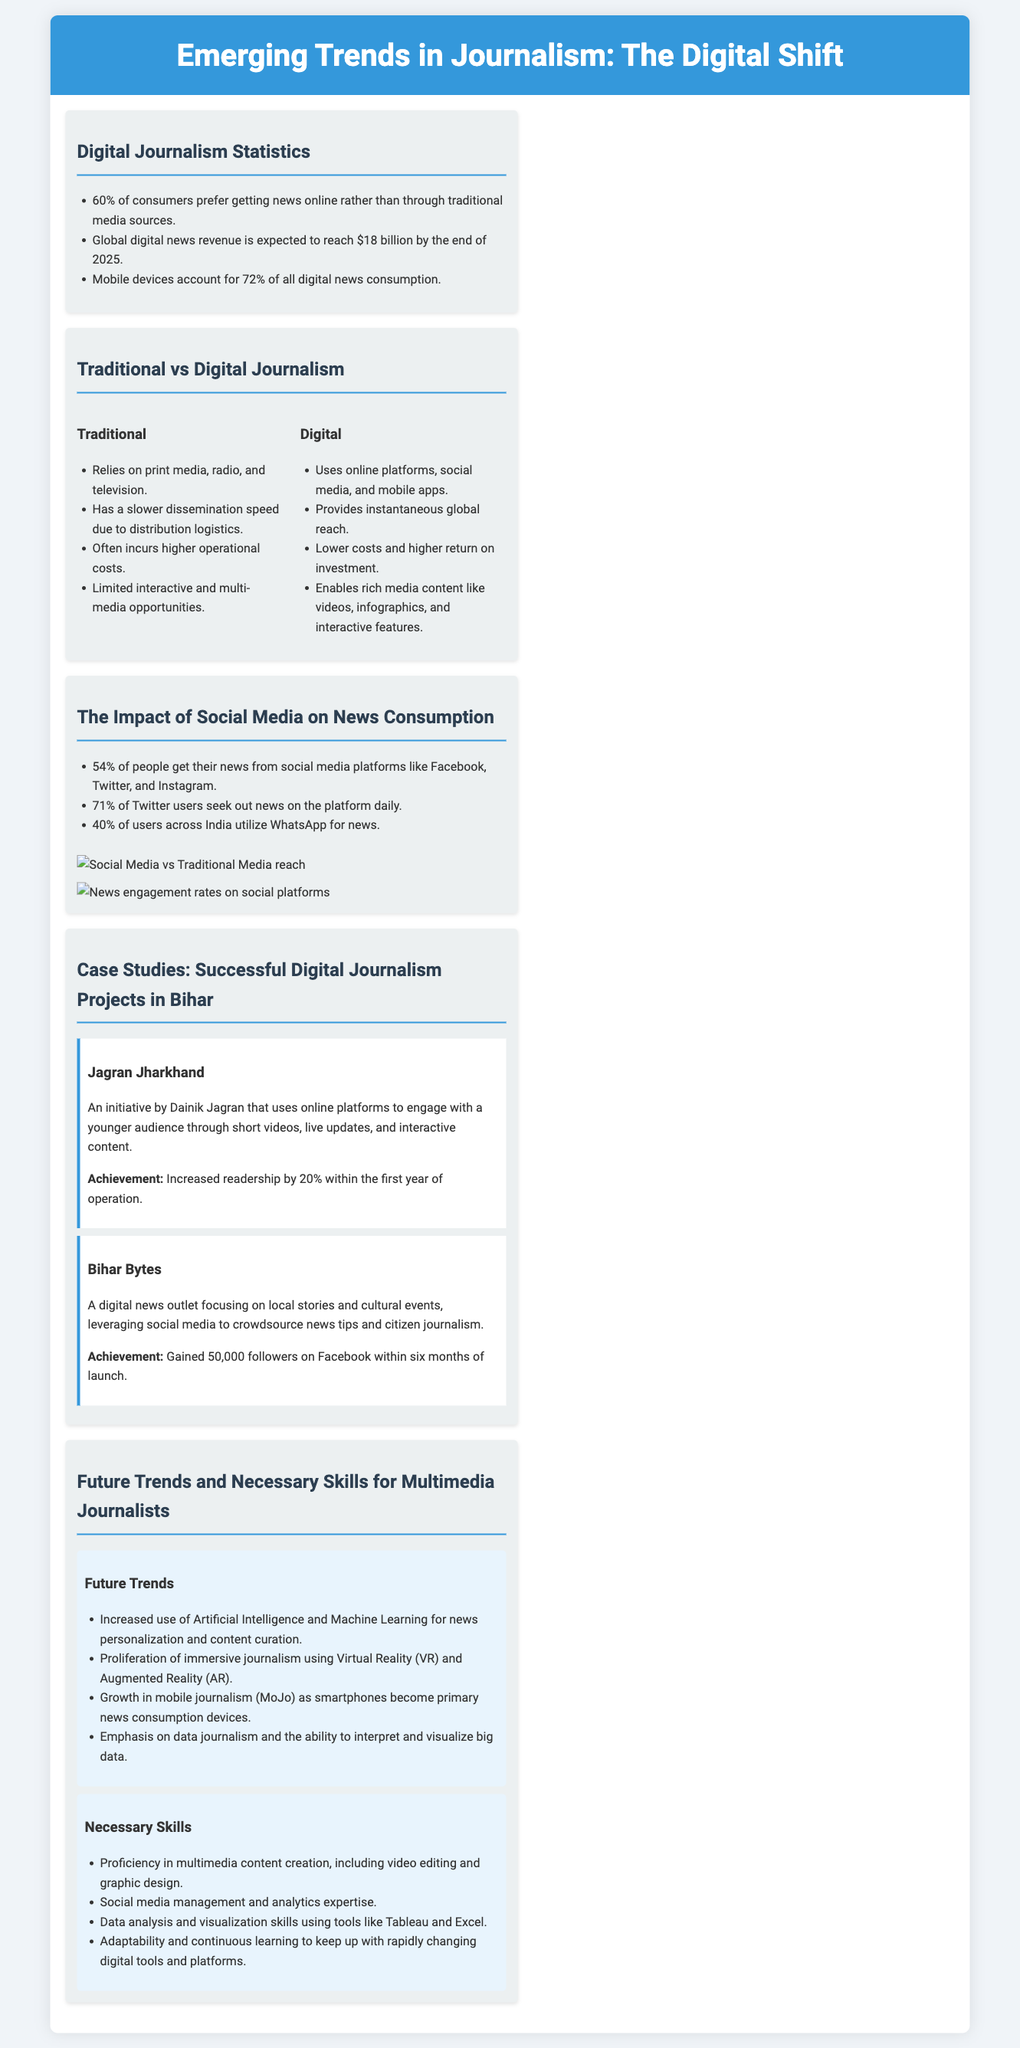What percentage of consumers prefer getting news online? The document states that 60% of consumers prefer digital news over traditional sources.
Answer: 60% What is the expected global digital news revenue by 2025? The document mentions that global digital news revenue is expected to reach $18 billion by the end of 2025.
Answer: $18 billion How many percent of people get their news from social media platforms? The document indicates that 54% of people get their news from social media platforms.
Answer: 54% What is one successful digital journalism project in Bihar? The document lists "Jagran Jharkhand" as one example of a successful project.
Answer: Jagran Jharkhand What is the increase in readership for Jagran Jharkhand? The document notes that Jagran Jharkhand increased readership by 20% within the first year of operation.
Answer: 20% What is one future trend mentioned for multimedia journalism? The document highlights the increased use of Artificial Intelligence for news personalization as a future trend.
Answer: Artificial Intelligence What skill is necessary for multimedia journalists according to the document? It states proficiency in multimedia content creation is necessary for multimedia journalists.
Answer: Multimedia content creation What percentage of Twitter users seek out news daily? The document states that 71% of Twitter users seek out news on the platform daily.
Answer: 71% How many followers did Bihar Bytes gain on Facebook? The document mentions that Bihar Bytes gained 50,000 followers on Facebook.
Answer: 50,000 